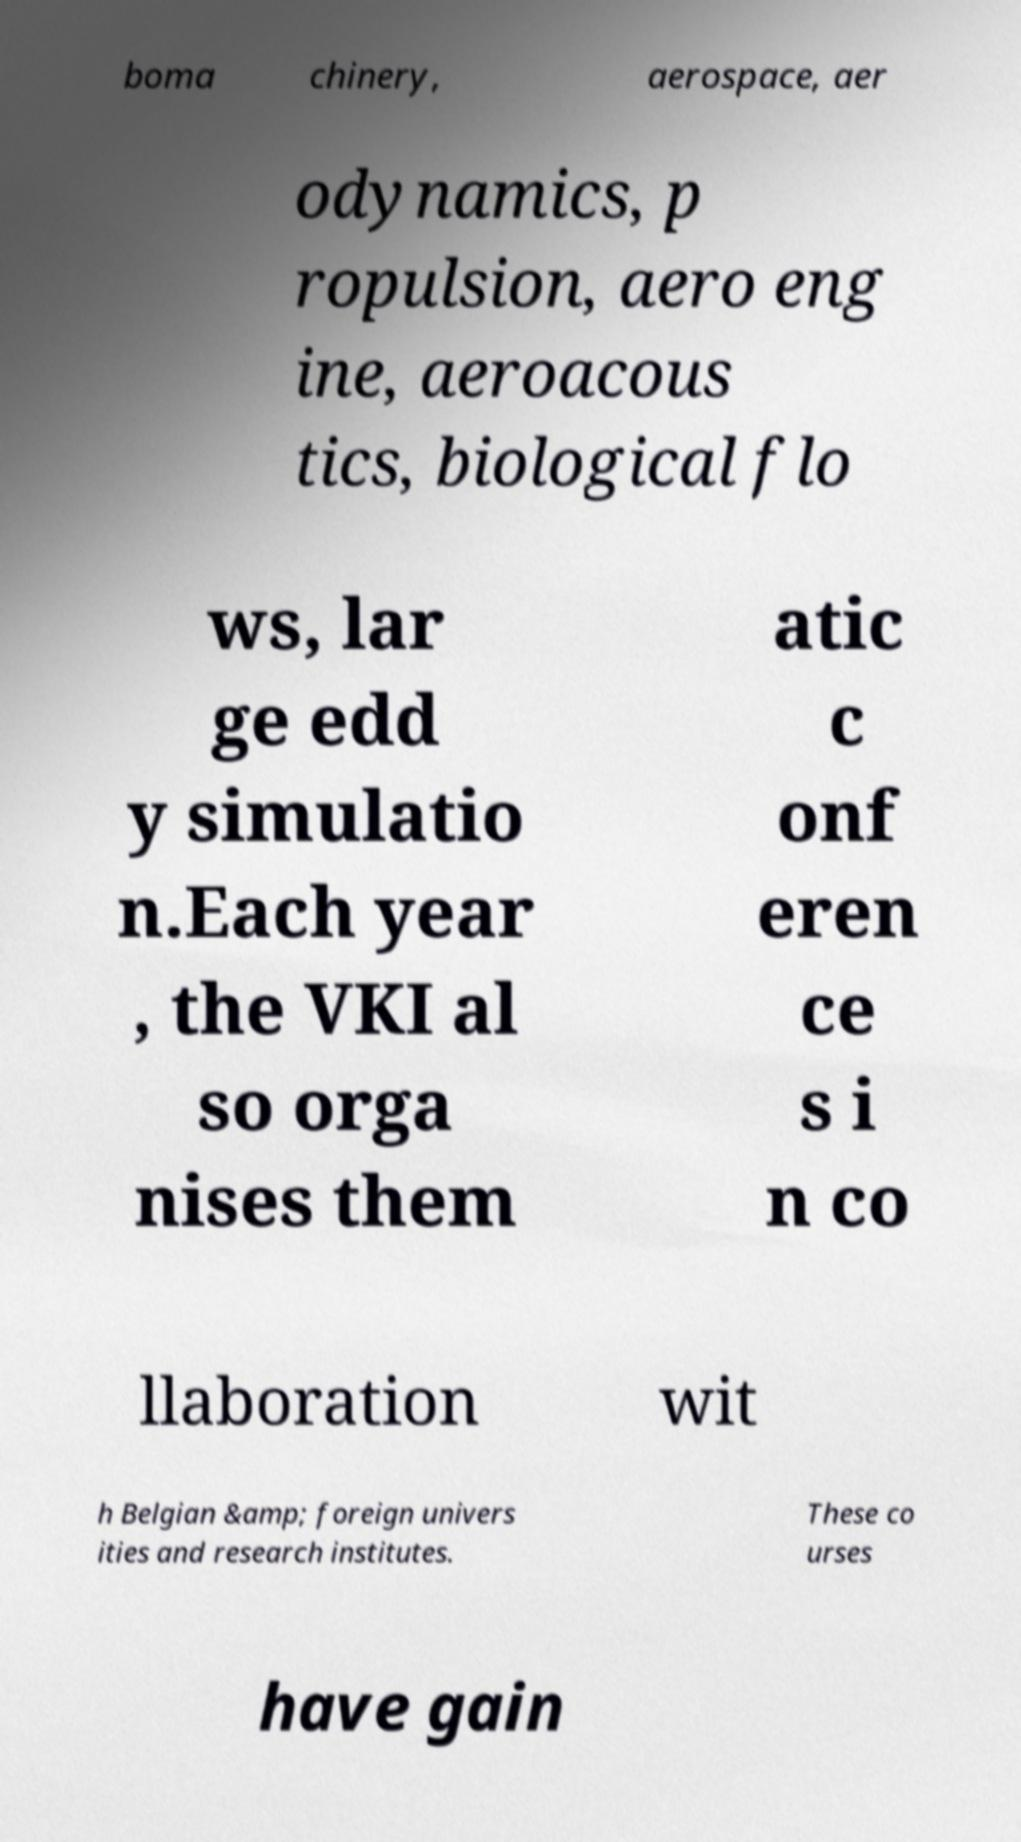Please read and relay the text visible in this image. What does it say? boma chinery, aerospace, aer odynamics, p ropulsion, aero eng ine, aeroacous tics, biological flo ws, lar ge edd y simulatio n.Each year , the VKI al so orga nises them atic c onf eren ce s i n co llaboration wit h Belgian &amp; foreign univers ities and research institutes. These co urses have gain 